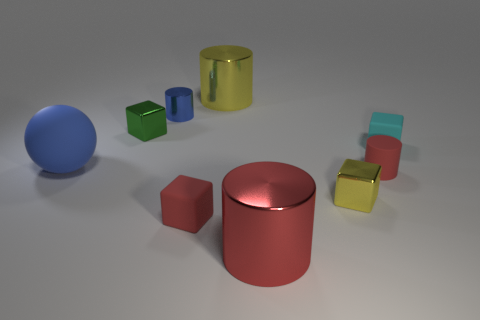What size is the shiny cylinder that is the same color as the sphere?
Your answer should be very brief. Small. What is the material of the object that is the same color as the tiny metal cylinder?
Make the answer very short. Rubber. Is the color of the matte object that is on the left side of the small blue shiny cylinder the same as the small metallic cylinder?
Offer a terse response. Yes. How many other objects are the same color as the matte cylinder?
Keep it short and to the point. 2. What material is the small red cube?
Keep it short and to the point. Rubber. How many other objects are the same material as the large red object?
Your response must be concise. 4. There is a shiny cylinder that is behind the large blue object and to the right of the small red block; what is its size?
Provide a short and direct response. Large. What is the shape of the large shiny object in front of the big blue rubber sphere that is in front of the big yellow metal cylinder?
Provide a succinct answer. Cylinder. Are there any other things that have the same shape as the blue matte thing?
Your answer should be very brief. No. Are there an equal number of green blocks behind the cyan rubber thing and big yellow shiny balls?
Provide a succinct answer. No. 